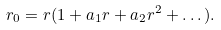<formula> <loc_0><loc_0><loc_500><loc_500>r _ { 0 } = r ( 1 + a _ { 1 } r + a _ { 2 } r ^ { 2 } + \dots ) .</formula> 